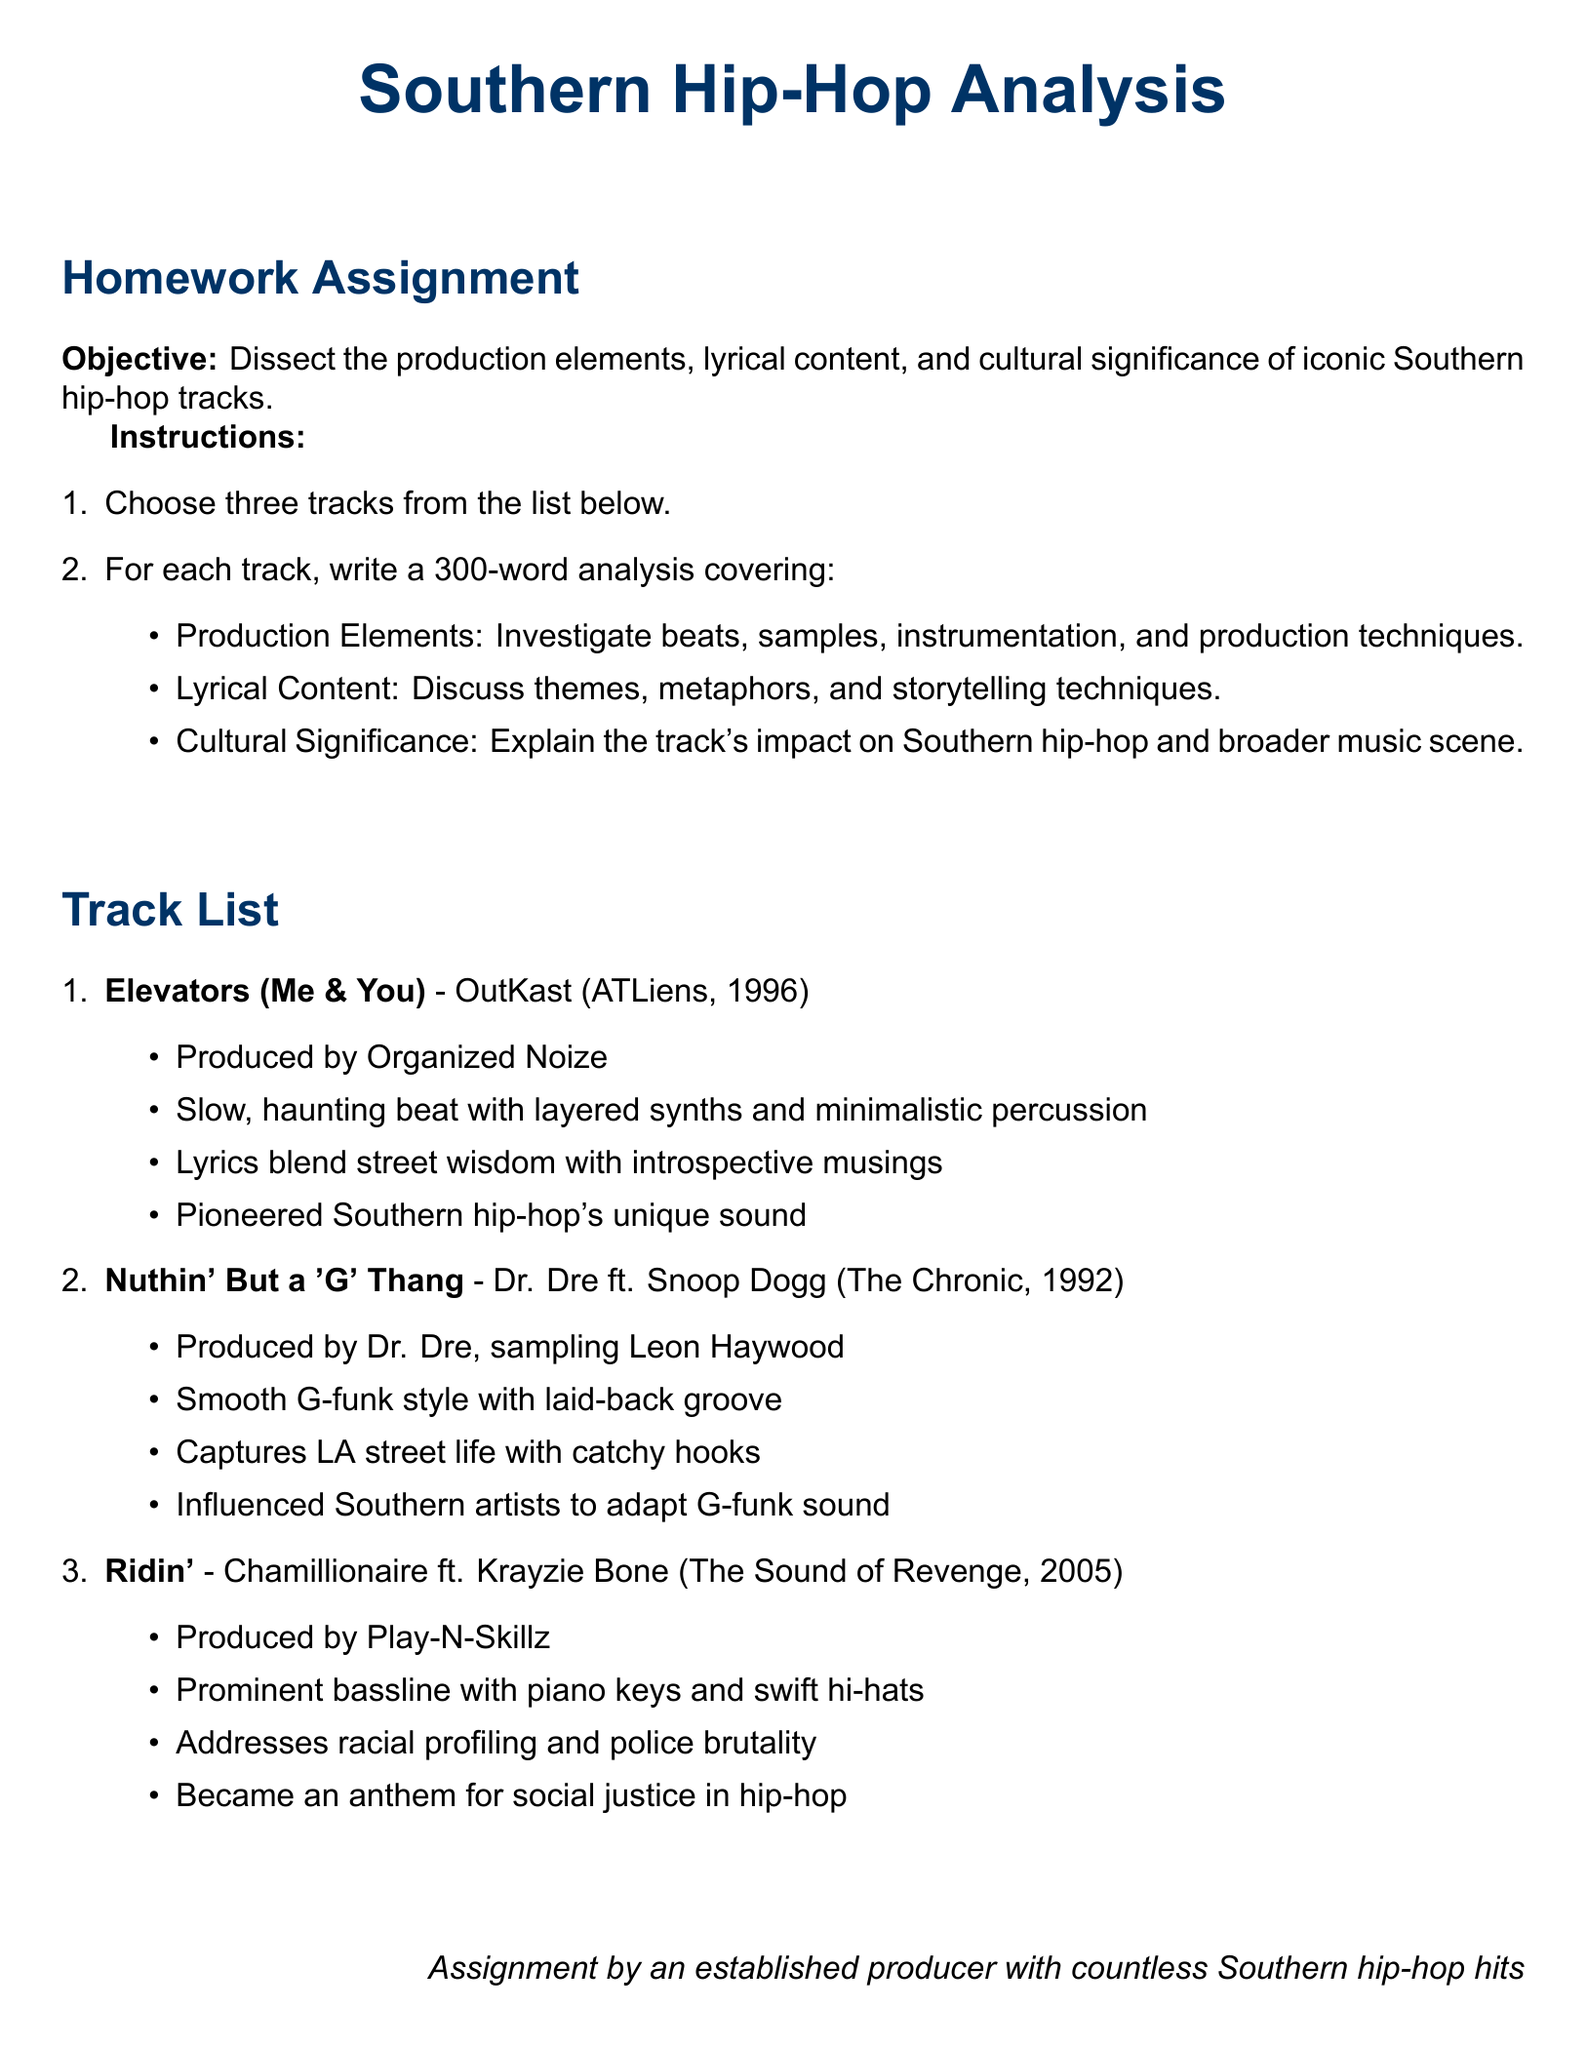What is the title of the homework assignment? The title is the main heading of the document, which indicates the subject matter to be analyzed.
Answer: Southern Hip-Hop Analysis Who produced "Elevators (Me & You)"? The document lists the producer for the track as part of its bullet points.
Answer: Organized Noize What year was "Nuthin' But a 'G' Thang" released? The year is mentioned in parentheses next to the track title in the list.
Answer: 1992 Which artist featured in "Ridin'" along with Chamillionaire? The document includes collaborative details under each track's bullet points.
Answer: Krayzie Bone What musical element is emphasized in "Ridin'"'s production? The homework assignment requires a focus on production elements, which are listed in the document for each track.
Answer: Prominent bassline How many words should each analysis cover? The instructions specify the required length of each track analysis.
Answer: 300 words Which track is mentioned as an anthem for social justice? The document explicitly states the cultural significance of "Ridin'" regarding social issues.
Answer: Ridin' What is one theme discussed in "Elevators (Me & You)" lyrics? The document outlines the lyrical content for each track, which includes themes.
Answer: Street wisdom What is the production style of "Nuthin' But a 'G' Thang"? The production style is described in the bullet points for the specific track.
Answer: Smooth G-funk style 